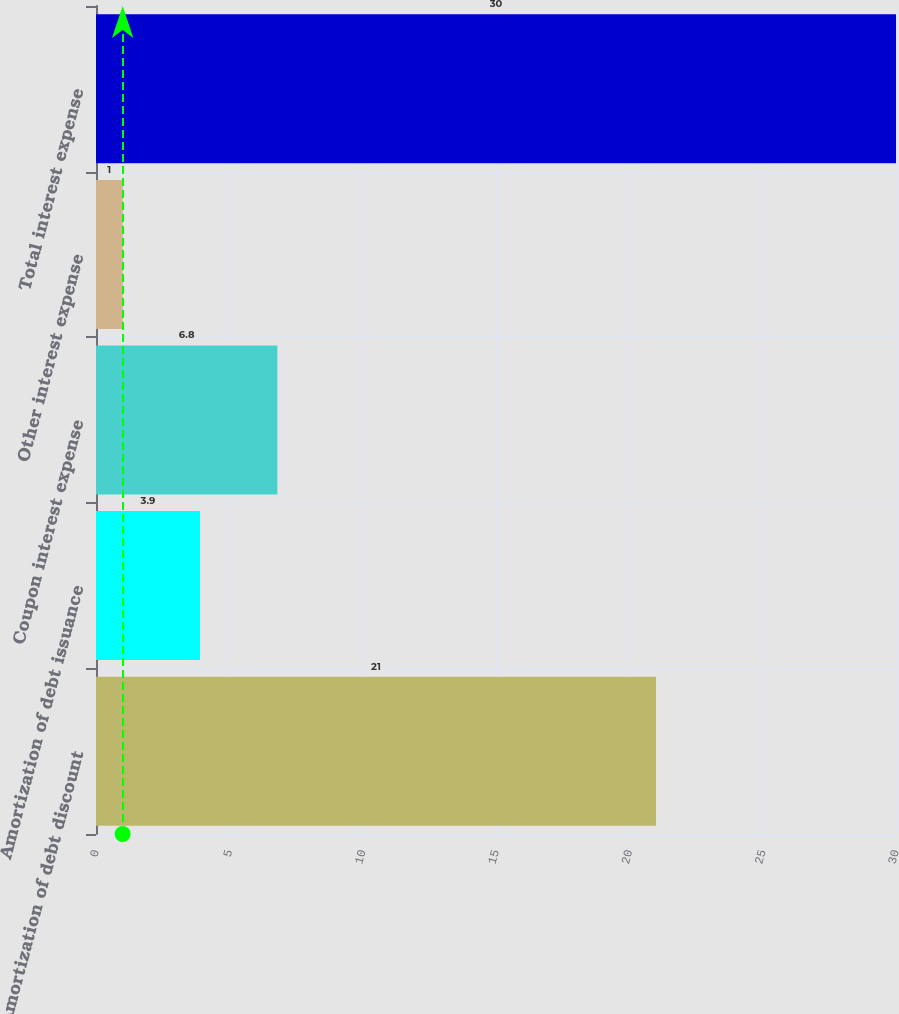Convert chart to OTSL. <chart><loc_0><loc_0><loc_500><loc_500><bar_chart><fcel>Amortization of debt discount<fcel>Amortization of debt issuance<fcel>Coupon interest expense<fcel>Other interest expense<fcel>Total interest expense<nl><fcel>21<fcel>3.9<fcel>6.8<fcel>1<fcel>30<nl></chart> 